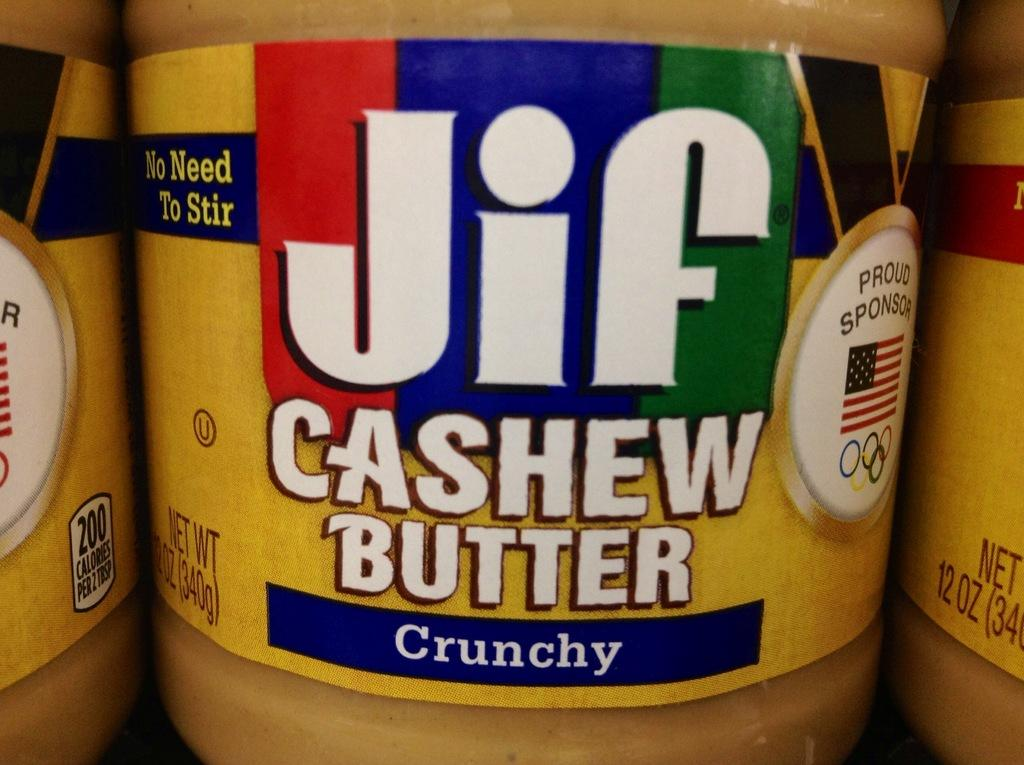<image>
Give a short and clear explanation of the subsequent image. a close up of Jif Cashew Butter Crunchy spread 